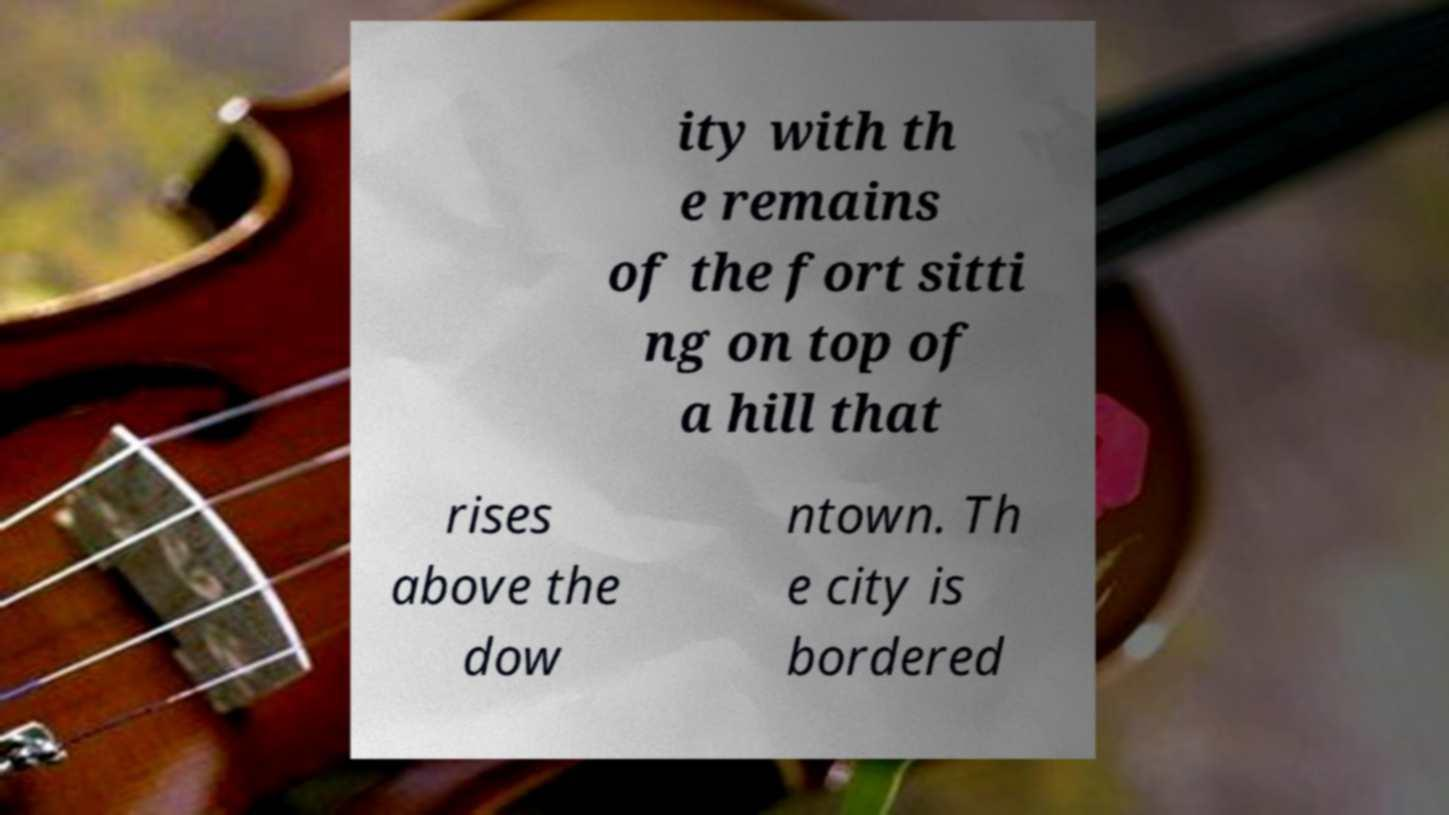Could you assist in decoding the text presented in this image and type it out clearly? ity with th e remains of the fort sitti ng on top of a hill that rises above the dow ntown. Th e city is bordered 